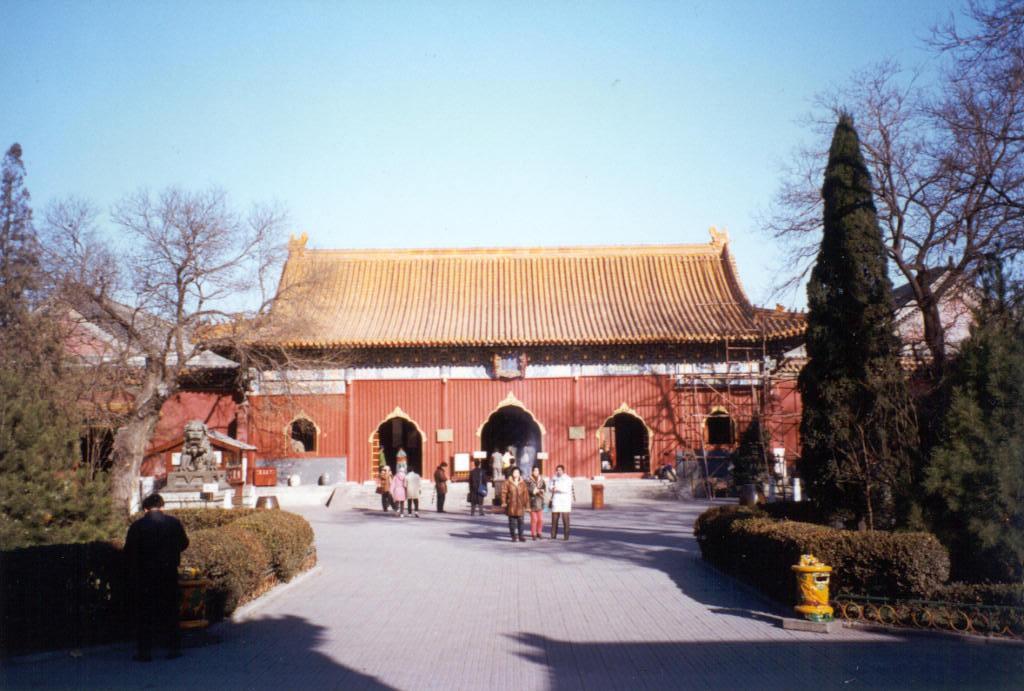Describe this image in one or two sentences. In this image we can see few persons are standing on a surface, trees, plants, objects, statue on a platform, houses, poles, roofs and sky. 